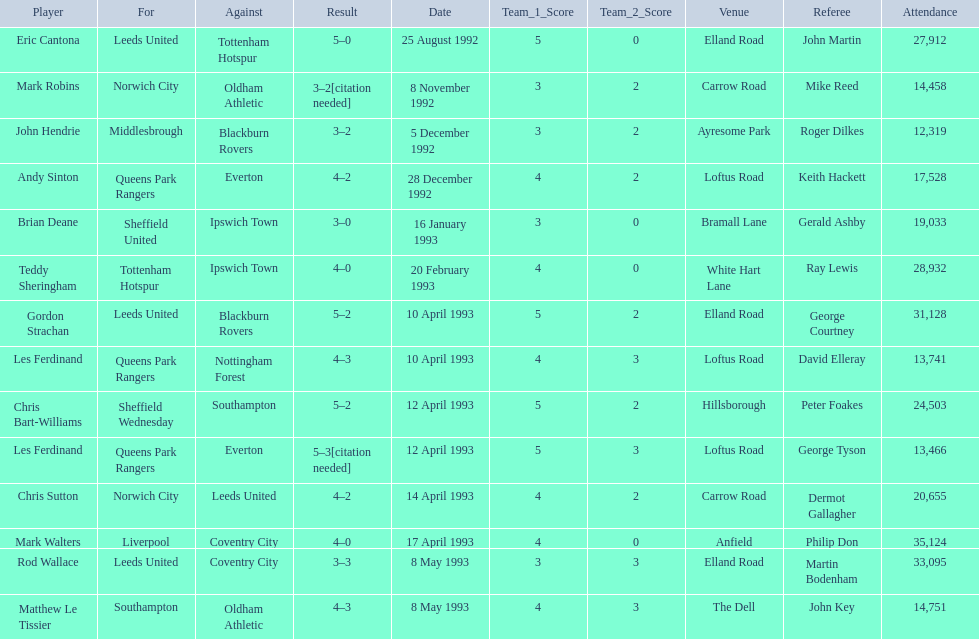What was the result of the match between queens park rangers and everton? 4-2. 